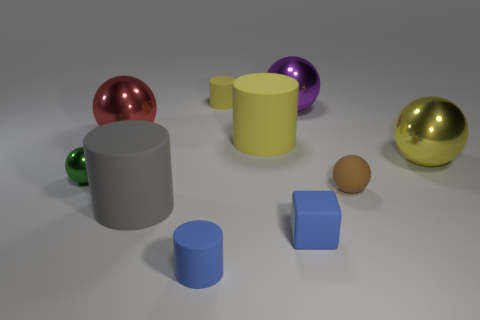What number of large things are in front of the large red shiny ball and left of the small yellow thing?
Ensure brevity in your answer.  1. The yellow matte thing left of the big cylinder that is behind the tiny sphere that is left of the big yellow matte thing is what shape?
Give a very brief answer. Cylinder. How many cubes are either big yellow matte objects or big matte objects?
Provide a short and direct response. 0. Do the tiny matte thing in front of the rubber cube and the tiny cube have the same color?
Offer a very short reply. Yes. What is the material of the big yellow ball on the right side of the large purple sphere that is on the right side of the tiny cylinder left of the small yellow cylinder?
Provide a short and direct response. Metal. Is the red metallic sphere the same size as the yellow shiny sphere?
Offer a very short reply. Yes. Is the color of the small rubber sphere the same as the small cylinder that is behind the red object?
Your answer should be compact. No. What shape is the large yellow thing that is the same material as the large gray cylinder?
Your answer should be compact. Cylinder. Is the shape of the matte thing behind the red ball the same as  the large gray object?
Provide a short and direct response. Yes. What is the size of the gray rubber object in front of the small sphere that is left of the rubber ball?
Your answer should be very brief. Large. 